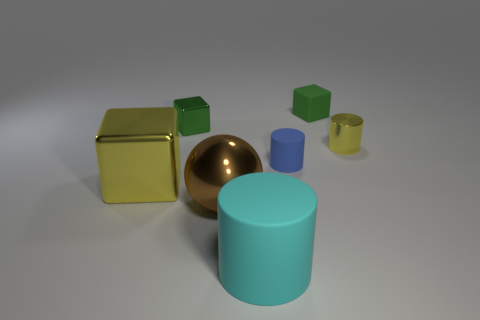Is there any pattern to the arrangement of objects in this image? There doesn't seem to be a specific pattern to the arrangement of the objects. They are placed sporadically, with varying distances between them. The composition might suggest a random or casual placement rather than a deliberate pattern. 